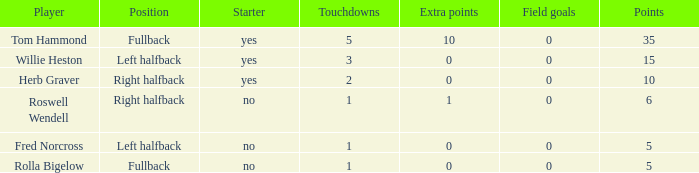How many more points did roswell wendell, the right halfback, accumulate? 1.0. 